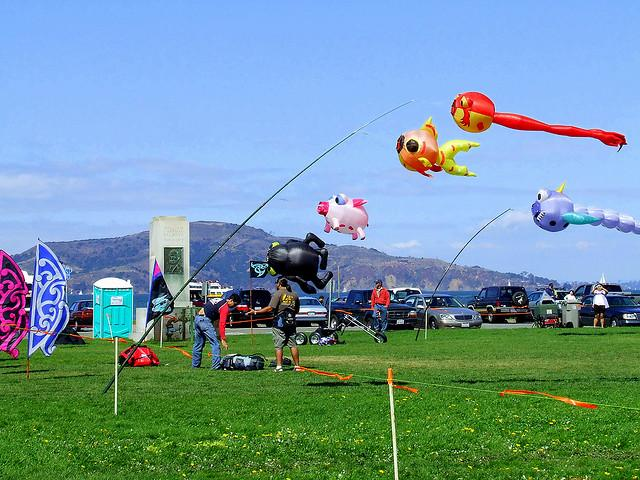Where can you reasonably go to the bathroom here? Please explain your reasoning. outhouse. A blue outhouse is seen in an open area with a parking lot behind. outhouses are used as bathrooms at outdoor venues. 